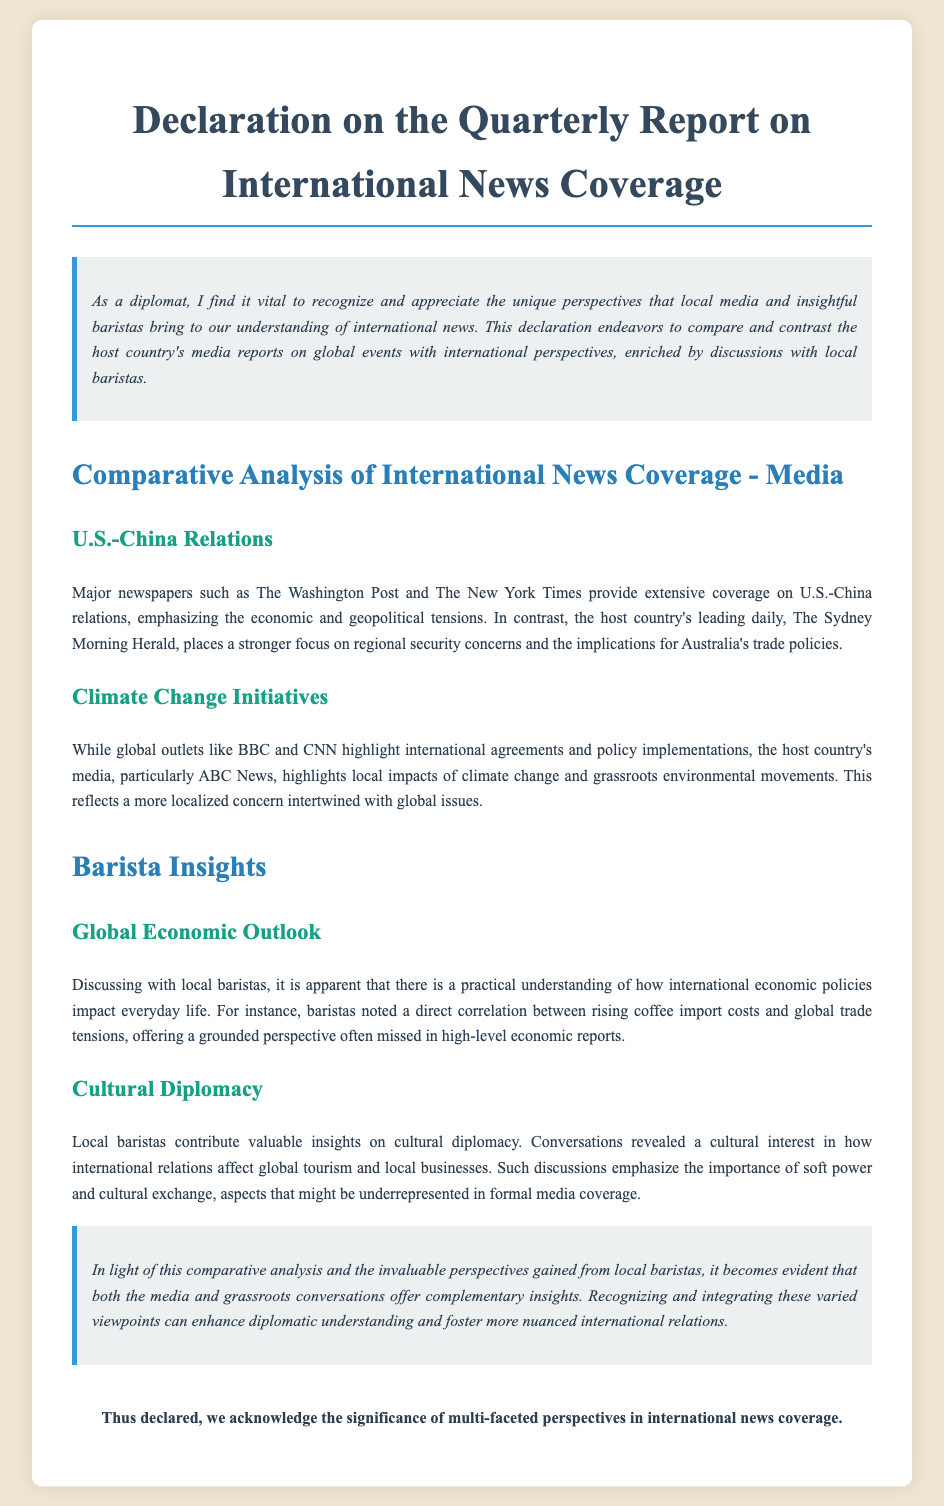What is the title of the document? The title is prominently displayed at the top of the document, which is "Declaration on the Quarterly Report on International News Coverage."
Answer: Declaration on the Quarterly Report on International News Coverage Which newspaper emphasizes regional security concerns? The document states that the host country's leading daily focuses on regional security concerns, specifically mentioning "The Sydney Morning Herald."
Answer: The Sydney Morning Herald What grassroots movement does the host country's media highlight? The document mentions that the host country's media highlights grassroots environmental movements in relation to climate change.
Answer: Grassroots environmental movements What correlation did baristas note regarding coffee import costs? According to local baristas, there is a correlation between rising coffee import costs and global trade tensions, as noted in the discussions.
Answer: Rising coffee import costs and global trade tensions What aspect of international relations did local baristas discuss? The baristas offered insights on cultural diplomacy, demonstrating a cultural interest in how international relations affect global tourism.
Answer: Cultural diplomacy What does the document suggest about the integration of perspectives? The statement emphasizes the importance of recognizing and integrating varied viewpoints to enhance diplomatic understanding.
Answer: Enhance diplomatic understanding How many sections are dedicated to barista insights? The document features two sections specifically addressing insights from local baristas, highlighting their valuable perspectives.
Answer: Two sections In which media outlet is climate change mentioned as a local concern? The document specifically refers to how "ABC News" focuses on local impacts of climate change.
Answer: ABC News 